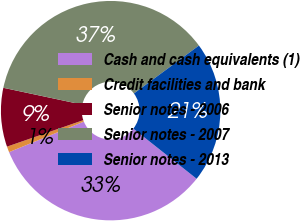<chart> <loc_0><loc_0><loc_500><loc_500><pie_chart><fcel>Cash and cash equivalents (1)<fcel>Credit facilities and bank<fcel>Senior notes - 2006<fcel>Senior notes - 2007<fcel>Senior notes - 2013<nl><fcel>33.16%<fcel>0.85%<fcel>8.66%<fcel>36.54%<fcel>20.77%<nl></chart> 